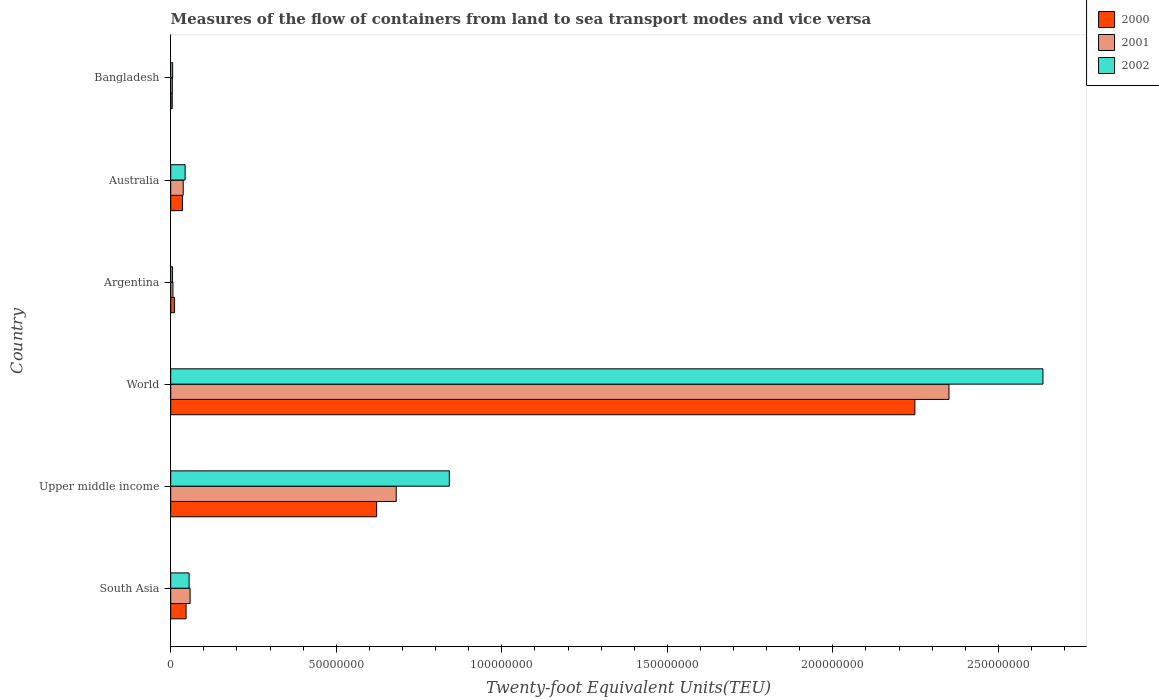How many groups of bars are there?
Offer a terse response. 6. Are the number of bars per tick equal to the number of legend labels?
Your answer should be very brief. Yes. Are the number of bars on each tick of the Y-axis equal?
Your response must be concise. Yes. How many bars are there on the 4th tick from the top?
Offer a very short reply. 3. How many bars are there on the 3rd tick from the bottom?
Give a very brief answer. 3. What is the container port traffic in 2001 in Bangladesh?
Offer a terse response. 4.86e+05. Across all countries, what is the maximum container port traffic in 2001?
Give a very brief answer. 2.35e+08. Across all countries, what is the minimum container port traffic in 2002?
Make the answer very short. 5.55e+05. In which country was the container port traffic in 2000 minimum?
Your answer should be compact. Bangladesh. What is the total container port traffic in 2001 in the graph?
Give a very brief answer. 3.14e+08. What is the difference between the container port traffic in 2002 in Australia and that in South Asia?
Offer a very short reply. -1.20e+06. What is the difference between the container port traffic in 2002 in Bangladesh and the container port traffic in 2000 in South Asia?
Provide a succinct answer. -4.06e+06. What is the average container port traffic in 2000 per country?
Offer a very short reply. 4.95e+07. What is the difference between the container port traffic in 2002 and container port traffic in 2001 in Argentina?
Provide a succinct answer. -1.09e+05. What is the ratio of the container port traffic in 2002 in South Asia to that in World?
Ensure brevity in your answer.  0.02. Is the container port traffic in 2000 in Australia less than that in Upper middle income?
Keep it short and to the point. Yes. What is the difference between the highest and the second highest container port traffic in 2000?
Make the answer very short. 1.63e+08. What is the difference between the highest and the lowest container port traffic in 2001?
Give a very brief answer. 2.35e+08. In how many countries, is the container port traffic in 2000 greater than the average container port traffic in 2000 taken over all countries?
Your response must be concise. 2. Is the sum of the container port traffic in 2000 in Australia and South Asia greater than the maximum container port traffic in 2002 across all countries?
Your response must be concise. No. What does the 1st bar from the bottom in World represents?
Your response must be concise. 2000. Is it the case that in every country, the sum of the container port traffic in 2002 and container port traffic in 2001 is greater than the container port traffic in 2000?
Provide a succinct answer. Yes. How many bars are there?
Offer a very short reply. 18. What is the difference between two consecutive major ticks on the X-axis?
Your answer should be compact. 5.00e+07. Are the values on the major ticks of X-axis written in scientific E-notation?
Ensure brevity in your answer.  No. Does the graph contain any zero values?
Offer a terse response. No. Does the graph contain grids?
Provide a short and direct response. No. Where does the legend appear in the graph?
Provide a succinct answer. Top right. What is the title of the graph?
Offer a terse response. Measures of the flow of containers from land to sea transport modes and vice versa. Does "2006" appear as one of the legend labels in the graph?
Your answer should be very brief. No. What is the label or title of the X-axis?
Make the answer very short. Twenty-foot Equivalent Units(TEU). What is the label or title of the Y-axis?
Ensure brevity in your answer.  Country. What is the Twenty-foot Equivalent Units(TEU) of 2000 in South Asia?
Your answer should be very brief. 4.64e+06. What is the Twenty-foot Equivalent Units(TEU) in 2001 in South Asia?
Make the answer very short. 5.86e+06. What is the Twenty-foot Equivalent Units(TEU) of 2002 in South Asia?
Give a very brief answer. 5.56e+06. What is the Twenty-foot Equivalent Units(TEU) of 2000 in Upper middle income?
Your answer should be very brief. 6.22e+07. What is the Twenty-foot Equivalent Units(TEU) of 2001 in Upper middle income?
Make the answer very short. 6.81e+07. What is the Twenty-foot Equivalent Units(TEU) in 2002 in Upper middle income?
Provide a short and direct response. 8.42e+07. What is the Twenty-foot Equivalent Units(TEU) in 2000 in World?
Give a very brief answer. 2.25e+08. What is the Twenty-foot Equivalent Units(TEU) of 2001 in World?
Make the answer very short. 2.35e+08. What is the Twenty-foot Equivalent Units(TEU) in 2002 in World?
Your answer should be very brief. 2.63e+08. What is the Twenty-foot Equivalent Units(TEU) of 2000 in Argentina?
Ensure brevity in your answer.  1.14e+06. What is the Twenty-foot Equivalent Units(TEU) of 2001 in Argentina?
Ensure brevity in your answer.  6.64e+05. What is the Twenty-foot Equivalent Units(TEU) of 2002 in Argentina?
Offer a very short reply. 5.55e+05. What is the Twenty-foot Equivalent Units(TEU) of 2000 in Australia?
Offer a very short reply. 3.54e+06. What is the Twenty-foot Equivalent Units(TEU) in 2001 in Australia?
Offer a terse response. 3.77e+06. What is the Twenty-foot Equivalent Units(TEU) in 2002 in Australia?
Your answer should be very brief. 4.36e+06. What is the Twenty-foot Equivalent Units(TEU) in 2000 in Bangladesh?
Your answer should be very brief. 4.56e+05. What is the Twenty-foot Equivalent Units(TEU) in 2001 in Bangladesh?
Make the answer very short. 4.86e+05. What is the Twenty-foot Equivalent Units(TEU) in 2002 in Bangladesh?
Provide a short and direct response. 5.84e+05. Across all countries, what is the maximum Twenty-foot Equivalent Units(TEU) in 2000?
Ensure brevity in your answer.  2.25e+08. Across all countries, what is the maximum Twenty-foot Equivalent Units(TEU) of 2001?
Your answer should be very brief. 2.35e+08. Across all countries, what is the maximum Twenty-foot Equivalent Units(TEU) of 2002?
Provide a succinct answer. 2.63e+08. Across all countries, what is the minimum Twenty-foot Equivalent Units(TEU) of 2000?
Provide a short and direct response. 4.56e+05. Across all countries, what is the minimum Twenty-foot Equivalent Units(TEU) of 2001?
Offer a very short reply. 4.86e+05. Across all countries, what is the minimum Twenty-foot Equivalent Units(TEU) of 2002?
Provide a succinct answer. 5.55e+05. What is the total Twenty-foot Equivalent Units(TEU) of 2000 in the graph?
Your response must be concise. 2.97e+08. What is the total Twenty-foot Equivalent Units(TEU) of 2001 in the graph?
Make the answer very short. 3.14e+08. What is the total Twenty-foot Equivalent Units(TEU) of 2002 in the graph?
Make the answer very short. 3.59e+08. What is the difference between the Twenty-foot Equivalent Units(TEU) of 2000 in South Asia and that in Upper middle income?
Give a very brief answer. -5.76e+07. What is the difference between the Twenty-foot Equivalent Units(TEU) of 2001 in South Asia and that in Upper middle income?
Provide a short and direct response. -6.23e+07. What is the difference between the Twenty-foot Equivalent Units(TEU) in 2002 in South Asia and that in Upper middle income?
Your answer should be compact. -7.86e+07. What is the difference between the Twenty-foot Equivalent Units(TEU) of 2000 in South Asia and that in World?
Ensure brevity in your answer.  -2.20e+08. What is the difference between the Twenty-foot Equivalent Units(TEU) of 2001 in South Asia and that in World?
Ensure brevity in your answer.  -2.29e+08. What is the difference between the Twenty-foot Equivalent Units(TEU) of 2002 in South Asia and that in World?
Your response must be concise. -2.58e+08. What is the difference between the Twenty-foot Equivalent Units(TEU) of 2000 in South Asia and that in Argentina?
Your response must be concise. 3.49e+06. What is the difference between the Twenty-foot Equivalent Units(TEU) in 2001 in South Asia and that in Argentina?
Provide a succinct answer. 5.19e+06. What is the difference between the Twenty-foot Equivalent Units(TEU) in 2002 in South Asia and that in Argentina?
Provide a succinct answer. 5.00e+06. What is the difference between the Twenty-foot Equivalent Units(TEU) of 2000 in South Asia and that in Australia?
Your answer should be very brief. 1.10e+06. What is the difference between the Twenty-foot Equivalent Units(TEU) of 2001 in South Asia and that in Australia?
Offer a very short reply. 2.08e+06. What is the difference between the Twenty-foot Equivalent Units(TEU) of 2002 in South Asia and that in Australia?
Provide a short and direct response. 1.20e+06. What is the difference between the Twenty-foot Equivalent Units(TEU) of 2000 in South Asia and that in Bangladesh?
Ensure brevity in your answer.  4.18e+06. What is the difference between the Twenty-foot Equivalent Units(TEU) in 2001 in South Asia and that in Bangladesh?
Your response must be concise. 5.37e+06. What is the difference between the Twenty-foot Equivalent Units(TEU) of 2002 in South Asia and that in Bangladesh?
Make the answer very short. 4.97e+06. What is the difference between the Twenty-foot Equivalent Units(TEU) of 2000 in Upper middle income and that in World?
Offer a very short reply. -1.63e+08. What is the difference between the Twenty-foot Equivalent Units(TEU) in 2001 in Upper middle income and that in World?
Provide a short and direct response. -1.67e+08. What is the difference between the Twenty-foot Equivalent Units(TEU) of 2002 in Upper middle income and that in World?
Your answer should be compact. -1.79e+08. What is the difference between the Twenty-foot Equivalent Units(TEU) of 2000 in Upper middle income and that in Argentina?
Keep it short and to the point. 6.11e+07. What is the difference between the Twenty-foot Equivalent Units(TEU) of 2001 in Upper middle income and that in Argentina?
Provide a succinct answer. 6.75e+07. What is the difference between the Twenty-foot Equivalent Units(TEU) of 2002 in Upper middle income and that in Argentina?
Ensure brevity in your answer.  8.36e+07. What is the difference between the Twenty-foot Equivalent Units(TEU) of 2000 in Upper middle income and that in Australia?
Your answer should be very brief. 5.87e+07. What is the difference between the Twenty-foot Equivalent Units(TEU) of 2001 in Upper middle income and that in Australia?
Give a very brief answer. 6.43e+07. What is the difference between the Twenty-foot Equivalent Units(TEU) of 2002 in Upper middle income and that in Australia?
Keep it short and to the point. 7.98e+07. What is the difference between the Twenty-foot Equivalent Units(TEU) of 2000 in Upper middle income and that in Bangladesh?
Offer a terse response. 6.17e+07. What is the difference between the Twenty-foot Equivalent Units(TEU) in 2001 in Upper middle income and that in Bangladesh?
Your answer should be compact. 6.76e+07. What is the difference between the Twenty-foot Equivalent Units(TEU) of 2002 in Upper middle income and that in Bangladesh?
Your answer should be very brief. 8.36e+07. What is the difference between the Twenty-foot Equivalent Units(TEU) of 2000 in World and that in Argentina?
Keep it short and to the point. 2.24e+08. What is the difference between the Twenty-foot Equivalent Units(TEU) in 2001 in World and that in Argentina?
Offer a very short reply. 2.34e+08. What is the difference between the Twenty-foot Equivalent Units(TEU) of 2002 in World and that in Argentina?
Give a very brief answer. 2.63e+08. What is the difference between the Twenty-foot Equivalent Units(TEU) of 2000 in World and that in Australia?
Provide a short and direct response. 2.21e+08. What is the difference between the Twenty-foot Equivalent Units(TEU) of 2001 in World and that in Australia?
Provide a short and direct response. 2.31e+08. What is the difference between the Twenty-foot Equivalent Units(TEU) of 2002 in World and that in Australia?
Your response must be concise. 2.59e+08. What is the difference between the Twenty-foot Equivalent Units(TEU) of 2000 in World and that in Bangladesh?
Your response must be concise. 2.24e+08. What is the difference between the Twenty-foot Equivalent Units(TEU) of 2001 in World and that in Bangladesh?
Give a very brief answer. 2.35e+08. What is the difference between the Twenty-foot Equivalent Units(TEU) in 2002 in World and that in Bangladesh?
Give a very brief answer. 2.63e+08. What is the difference between the Twenty-foot Equivalent Units(TEU) in 2000 in Argentina and that in Australia?
Keep it short and to the point. -2.40e+06. What is the difference between the Twenty-foot Equivalent Units(TEU) in 2001 in Argentina and that in Australia?
Offer a very short reply. -3.11e+06. What is the difference between the Twenty-foot Equivalent Units(TEU) of 2002 in Argentina and that in Australia?
Keep it short and to the point. -3.80e+06. What is the difference between the Twenty-foot Equivalent Units(TEU) of 2000 in Argentina and that in Bangladesh?
Offer a terse response. 6.89e+05. What is the difference between the Twenty-foot Equivalent Units(TEU) in 2001 in Argentina and that in Bangladesh?
Ensure brevity in your answer.  1.78e+05. What is the difference between the Twenty-foot Equivalent Units(TEU) of 2002 in Argentina and that in Bangladesh?
Your answer should be very brief. -2.94e+04. What is the difference between the Twenty-foot Equivalent Units(TEU) in 2000 in Australia and that in Bangladesh?
Your answer should be compact. 3.09e+06. What is the difference between the Twenty-foot Equivalent Units(TEU) in 2001 in Australia and that in Bangladesh?
Make the answer very short. 3.29e+06. What is the difference between the Twenty-foot Equivalent Units(TEU) in 2002 in Australia and that in Bangladesh?
Your answer should be compact. 3.77e+06. What is the difference between the Twenty-foot Equivalent Units(TEU) in 2000 in South Asia and the Twenty-foot Equivalent Units(TEU) in 2001 in Upper middle income?
Your response must be concise. -6.35e+07. What is the difference between the Twenty-foot Equivalent Units(TEU) of 2000 in South Asia and the Twenty-foot Equivalent Units(TEU) of 2002 in Upper middle income?
Your answer should be compact. -7.95e+07. What is the difference between the Twenty-foot Equivalent Units(TEU) in 2001 in South Asia and the Twenty-foot Equivalent Units(TEU) in 2002 in Upper middle income?
Keep it short and to the point. -7.83e+07. What is the difference between the Twenty-foot Equivalent Units(TEU) of 2000 in South Asia and the Twenty-foot Equivalent Units(TEU) of 2001 in World?
Ensure brevity in your answer.  -2.30e+08. What is the difference between the Twenty-foot Equivalent Units(TEU) in 2000 in South Asia and the Twenty-foot Equivalent Units(TEU) in 2002 in World?
Make the answer very short. -2.59e+08. What is the difference between the Twenty-foot Equivalent Units(TEU) of 2001 in South Asia and the Twenty-foot Equivalent Units(TEU) of 2002 in World?
Your answer should be compact. -2.58e+08. What is the difference between the Twenty-foot Equivalent Units(TEU) in 2000 in South Asia and the Twenty-foot Equivalent Units(TEU) in 2001 in Argentina?
Provide a short and direct response. 3.98e+06. What is the difference between the Twenty-foot Equivalent Units(TEU) in 2000 in South Asia and the Twenty-foot Equivalent Units(TEU) in 2002 in Argentina?
Ensure brevity in your answer.  4.08e+06. What is the difference between the Twenty-foot Equivalent Units(TEU) of 2001 in South Asia and the Twenty-foot Equivalent Units(TEU) of 2002 in Argentina?
Your answer should be compact. 5.30e+06. What is the difference between the Twenty-foot Equivalent Units(TEU) in 2000 in South Asia and the Twenty-foot Equivalent Units(TEU) in 2001 in Australia?
Give a very brief answer. 8.65e+05. What is the difference between the Twenty-foot Equivalent Units(TEU) of 2000 in South Asia and the Twenty-foot Equivalent Units(TEU) of 2002 in Australia?
Your answer should be compact. 2.84e+05. What is the difference between the Twenty-foot Equivalent Units(TEU) in 2001 in South Asia and the Twenty-foot Equivalent Units(TEU) in 2002 in Australia?
Provide a succinct answer. 1.50e+06. What is the difference between the Twenty-foot Equivalent Units(TEU) in 2000 in South Asia and the Twenty-foot Equivalent Units(TEU) in 2001 in Bangladesh?
Make the answer very short. 4.15e+06. What is the difference between the Twenty-foot Equivalent Units(TEU) of 2000 in South Asia and the Twenty-foot Equivalent Units(TEU) of 2002 in Bangladesh?
Make the answer very short. 4.06e+06. What is the difference between the Twenty-foot Equivalent Units(TEU) of 2001 in South Asia and the Twenty-foot Equivalent Units(TEU) of 2002 in Bangladesh?
Make the answer very short. 5.27e+06. What is the difference between the Twenty-foot Equivalent Units(TEU) in 2000 in Upper middle income and the Twenty-foot Equivalent Units(TEU) in 2001 in World?
Keep it short and to the point. -1.73e+08. What is the difference between the Twenty-foot Equivalent Units(TEU) of 2000 in Upper middle income and the Twenty-foot Equivalent Units(TEU) of 2002 in World?
Offer a very short reply. -2.01e+08. What is the difference between the Twenty-foot Equivalent Units(TEU) in 2001 in Upper middle income and the Twenty-foot Equivalent Units(TEU) in 2002 in World?
Keep it short and to the point. -1.95e+08. What is the difference between the Twenty-foot Equivalent Units(TEU) of 2000 in Upper middle income and the Twenty-foot Equivalent Units(TEU) of 2001 in Argentina?
Offer a very short reply. 6.15e+07. What is the difference between the Twenty-foot Equivalent Units(TEU) in 2000 in Upper middle income and the Twenty-foot Equivalent Units(TEU) in 2002 in Argentina?
Provide a short and direct response. 6.16e+07. What is the difference between the Twenty-foot Equivalent Units(TEU) in 2001 in Upper middle income and the Twenty-foot Equivalent Units(TEU) in 2002 in Argentina?
Your response must be concise. 6.76e+07. What is the difference between the Twenty-foot Equivalent Units(TEU) of 2000 in Upper middle income and the Twenty-foot Equivalent Units(TEU) of 2001 in Australia?
Your answer should be very brief. 5.84e+07. What is the difference between the Twenty-foot Equivalent Units(TEU) of 2000 in Upper middle income and the Twenty-foot Equivalent Units(TEU) of 2002 in Australia?
Keep it short and to the point. 5.78e+07. What is the difference between the Twenty-foot Equivalent Units(TEU) in 2001 in Upper middle income and the Twenty-foot Equivalent Units(TEU) in 2002 in Australia?
Ensure brevity in your answer.  6.38e+07. What is the difference between the Twenty-foot Equivalent Units(TEU) of 2000 in Upper middle income and the Twenty-foot Equivalent Units(TEU) of 2001 in Bangladesh?
Provide a short and direct response. 6.17e+07. What is the difference between the Twenty-foot Equivalent Units(TEU) of 2000 in Upper middle income and the Twenty-foot Equivalent Units(TEU) of 2002 in Bangladesh?
Your answer should be very brief. 6.16e+07. What is the difference between the Twenty-foot Equivalent Units(TEU) of 2001 in Upper middle income and the Twenty-foot Equivalent Units(TEU) of 2002 in Bangladesh?
Offer a terse response. 6.75e+07. What is the difference between the Twenty-foot Equivalent Units(TEU) of 2000 in World and the Twenty-foot Equivalent Units(TEU) of 2001 in Argentina?
Offer a very short reply. 2.24e+08. What is the difference between the Twenty-foot Equivalent Units(TEU) in 2000 in World and the Twenty-foot Equivalent Units(TEU) in 2002 in Argentina?
Make the answer very short. 2.24e+08. What is the difference between the Twenty-foot Equivalent Units(TEU) in 2001 in World and the Twenty-foot Equivalent Units(TEU) in 2002 in Argentina?
Provide a succinct answer. 2.35e+08. What is the difference between the Twenty-foot Equivalent Units(TEU) of 2000 in World and the Twenty-foot Equivalent Units(TEU) of 2001 in Australia?
Give a very brief answer. 2.21e+08. What is the difference between the Twenty-foot Equivalent Units(TEU) in 2000 in World and the Twenty-foot Equivalent Units(TEU) in 2002 in Australia?
Provide a short and direct response. 2.20e+08. What is the difference between the Twenty-foot Equivalent Units(TEU) of 2001 in World and the Twenty-foot Equivalent Units(TEU) of 2002 in Australia?
Keep it short and to the point. 2.31e+08. What is the difference between the Twenty-foot Equivalent Units(TEU) in 2000 in World and the Twenty-foot Equivalent Units(TEU) in 2001 in Bangladesh?
Keep it short and to the point. 2.24e+08. What is the difference between the Twenty-foot Equivalent Units(TEU) in 2000 in World and the Twenty-foot Equivalent Units(TEU) in 2002 in Bangladesh?
Offer a very short reply. 2.24e+08. What is the difference between the Twenty-foot Equivalent Units(TEU) of 2001 in World and the Twenty-foot Equivalent Units(TEU) of 2002 in Bangladesh?
Your answer should be very brief. 2.34e+08. What is the difference between the Twenty-foot Equivalent Units(TEU) in 2000 in Argentina and the Twenty-foot Equivalent Units(TEU) in 2001 in Australia?
Provide a short and direct response. -2.63e+06. What is the difference between the Twenty-foot Equivalent Units(TEU) of 2000 in Argentina and the Twenty-foot Equivalent Units(TEU) of 2002 in Australia?
Your answer should be compact. -3.21e+06. What is the difference between the Twenty-foot Equivalent Units(TEU) in 2001 in Argentina and the Twenty-foot Equivalent Units(TEU) in 2002 in Australia?
Make the answer very short. -3.69e+06. What is the difference between the Twenty-foot Equivalent Units(TEU) in 2000 in Argentina and the Twenty-foot Equivalent Units(TEU) in 2001 in Bangladesh?
Offer a very short reply. 6.59e+05. What is the difference between the Twenty-foot Equivalent Units(TEU) in 2000 in Argentina and the Twenty-foot Equivalent Units(TEU) in 2002 in Bangladesh?
Offer a very short reply. 5.61e+05. What is the difference between the Twenty-foot Equivalent Units(TEU) in 2001 in Argentina and the Twenty-foot Equivalent Units(TEU) in 2002 in Bangladesh?
Make the answer very short. 7.96e+04. What is the difference between the Twenty-foot Equivalent Units(TEU) in 2000 in Australia and the Twenty-foot Equivalent Units(TEU) in 2001 in Bangladesh?
Your answer should be very brief. 3.06e+06. What is the difference between the Twenty-foot Equivalent Units(TEU) in 2000 in Australia and the Twenty-foot Equivalent Units(TEU) in 2002 in Bangladesh?
Ensure brevity in your answer.  2.96e+06. What is the difference between the Twenty-foot Equivalent Units(TEU) of 2001 in Australia and the Twenty-foot Equivalent Units(TEU) of 2002 in Bangladesh?
Provide a short and direct response. 3.19e+06. What is the average Twenty-foot Equivalent Units(TEU) in 2000 per country?
Ensure brevity in your answer.  4.95e+07. What is the average Twenty-foot Equivalent Units(TEU) of 2001 per country?
Offer a very short reply. 5.23e+07. What is the average Twenty-foot Equivalent Units(TEU) of 2002 per country?
Your response must be concise. 5.98e+07. What is the difference between the Twenty-foot Equivalent Units(TEU) in 2000 and Twenty-foot Equivalent Units(TEU) in 2001 in South Asia?
Ensure brevity in your answer.  -1.22e+06. What is the difference between the Twenty-foot Equivalent Units(TEU) in 2000 and Twenty-foot Equivalent Units(TEU) in 2002 in South Asia?
Provide a succinct answer. -9.18e+05. What is the difference between the Twenty-foot Equivalent Units(TEU) of 2001 and Twenty-foot Equivalent Units(TEU) of 2002 in South Asia?
Your answer should be very brief. 2.99e+05. What is the difference between the Twenty-foot Equivalent Units(TEU) of 2000 and Twenty-foot Equivalent Units(TEU) of 2001 in Upper middle income?
Ensure brevity in your answer.  -5.92e+06. What is the difference between the Twenty-foot Equivalent Units(TEU) of 2000 and Twenty-foot Equivalent Units(TEU) of 2002 in Upper middle income?
Provide a short and direct response. -2.20e+07. What is the difference between the Twenty-foot Equivalent Units(TEU) of 2001 and Twenty-foot Equivalent Units(TEU) of 2002 in Upper middle income?
Provide a succinct answer. -1.60e+07. What is the difference between the Twenty-foot Equivalent Units(TEU) of 2000 and Twenty-foot Equivalent Units(TEU) of 2001 in World?
Give a very brief answer. -1.03e+07. What is the difference between the Twenty-foot Equivalent Units(TEU) in 2000 and Twenty-foot Equivalent Units(TEU) in 2002 in World?
Ensure brevity in your answer.  -3.87e+07. What is the difference between the Twenty-foot Equivalent Units(TEU) in 2001 and Twenty-foot Equivalent Units(TEU) in 2002 in World?
Your response must be concise. -2.84e+07. What is the difference between the Twenty-foot Equivalent Units(TEU) in 2000 and Twenty-foot Equivalent Units(TEU) in 2001 in Argentina?
Give a very brief answer. 4.81e+05. What is the difference between the Twenty-foot Equivalent Units(TEU) in 2000 and Twenty-foot Equivalent Units(TEU) in 2002 in Argentina?
Provide a succinct answer. 5.90e+05. What is the difference between the Twenty-foot Equivalent Units(TEU) of 2001 and Twenty-foot Equivalent Units(TEU) of 2002 in Argentina?
Make the answer very short. 1.09e+05. What is the difference between the Twenty-foot Equivalent Units(TEU) in 2000 and Twenty-foot Equivalent Units(TEU) in 2001 in Australia?
Provide a short and direct response. -2.32e+05. What is the difference between the Twenty-foot Equivalent Units(TEU) in 2000 and Twenty-foot Equivalent Units(TEU) in 2002 in Australia?
Offer a terse response. -8.12e+05. What is the difference between the Twenty-foot Equivalent Units(TEU) in 2001 and Twenty-foot Equivalent Units(TEU) in 2002 in Australia?
Keep it short and to the point. -5.80e+05. What is the difference between the Twenty-foot Equivalent Units(TEU) of 2000 and Twenty-foot Equivalent Units(TEU) of 2001 in Bangladesh?
Your response must be concise. -3.03e+04. What is the difference between the Twenty-foot Equivalent Units(TEU) of 2000 and Twenty-foot Equivalent Units(TEU) of 2002 in Bangladesh?
Offer a very short reply. -1.28e+05. What is the difference between the Twenty-foot Equivalent Units(TEU) in 2001 and Twenty-foot Equivalent Units(TEU) in 2002 in Bangladesh?
Make the answer very short. -9.79e+04. What is the ratio of the Twenty-foot Equivalent Units(TEU) of 2000 in South Asia to that in Upper middle income?
Make the answer very short. 0.07. What is the ratio of the Twenty-foot Equivalent Units(TEU) in 2001 in South Asia to that in Upper middle income?
Offer a very short reply. 0.09. What is the ratio of the Twenty-foot Equivalent Units(TEU) of 2002 in South Asia to that in Upper middle income?
Ensure brevity in your answer.  0.07. What is the ratio of the Twenty-foot Equivalent Units(TEU) in 2000 in South Asia to that in World?
Ensure brevity in your answer.  0.02. What is the ratio of the Twenty-foot Equivalent Units(TEU) in 2001 in South Asia to that in World?
Provide a succinct answer. 0.02. What is the ratio of the Twenty-foot Equivalent Units(TEU) of 2002 in South Asia to that in World?
Offer a very short reply. 0.02. What is the ratio of the Twenty-foot Equivalent Units(TEU) of 2000 in South Asia to that in Argentina?
Provide a succinct answer. 4.05. What is the ratio of the Twenty-foot Equivalent Units(TEU) of 2001 in South Asia to that in Argentina?
Provide a short and direct response. 8.82. What is the ratio of the Twenty-foot Equivalent Units(TEU) in 2002 in South Asia to that in Argentina?
Your answer should be compact. 10.02. What is the ratio of the Twenty-foot Equivalent Units(TEU) in 2000 in South Asia to that in Australia?
Keep it short and to the point. 1.31. What is the ratio of the Twenty-foot Equivalent Units(TEU) of 2001 in South Asia to that in Australia?
Offer a terse response. 1.55. What is the ratio of the Twenty-foot Equivalent Units(TEU) of 2002 in South Asia to that in Australia?
Provide a short and direct response. 1.28. What is the ratio of the Twenty-foot Equivalent Units(TEU) of 2000 in South Asia to that in Bangladesh?
Offer a very short reply. 10.17. What is the ratio of the Twenty-foot Equivalent Units(TEU) of 2001 in South Asia to that in Bangladesh?
Offer a terse response. 12.04. What is the ratio of the Twenty-foot Equivalent Units(TEU) of 2002 in South Asia to that in Bangladesh?
Make the answer very short. 9.51. What is the ratio of the Twenty-foot Equivalent Units(TEU) in 2000 in Upper middle income to that in World?
Your answer should be compact. 0.28. What is the ratio of the Twenty-foot Equivalent Units(TEU) of 2001 in Upper middle income to that in World?
Provide a short and direct response. 0.29. What is the ratio of the Twenty-foot Equivalent Units(TEU) of 2002 in Upper middle income to that in World?
Provide a succinct answer. 0.32. What is the ratio of the Twenty-foot Equivalent Units(TEU) of 2000 in Upper middle income to that in Argentina?
Ensure brevity in your answer.  54.33. What is the ratio of the Twenty-foot Equivalent Units(TEU) in 2001 in Upper middle income to that in Argentina?
Offer a very short reply. 102.62. What is the ratio of the Twenty-foot Equivalent Units(TEU) of 2002 in Upper middle income to that in Argentina?
Your answer should be very brief. 151.68. What is the ratio of the Twenty-foot Equivalent Units(TEU) of 2000 in Upper middle income to that in Australia?
Your answer should be very brief. 17.56. What is the ratio of the Twenty-foot Equivalent Units(TEU) in 2001 in Upper middle income to that in Australia?
Keep it short and to the point. 18.05. What is the ratio of the Twenty-foot Equivalent Units(TEU) in 2002 in Upper middle income to that in Australia?
Keep it short and to the point. 19.32. What is the ratio of the Twenty-foot Equivalent Units(TEU) in 2000 in Upper middle income to that in Bangladesh?
Provide a short and direct response. 136.4. What is the ratio of the Twenty-foot Equivalent Units(TEU) in 2001 in Upper middle income to that in Bangladesh?
Your answer should be very brief. 140.08. What is the ratio of the Twenty-foot Equivalent Units(TEU) of 2002 in Upper middle income to that in Bangladesh?
Ensure brevity in your answer.  144.04. What is the ratio of the Twenty-foot Equivalent Units(TEU) in 2000 in World to that in Argentina?
Provide a short and direct response. 196.34. What is the ratio of the Twenty-foot Equivalent Units(TEU) of 2001 in World to that in Argentina?
Provide a succinct answer. 354.13. What is the ratio of the Twenty-foot Equivalent Units(TEU) in 2002 in World to that in Argentina?
Offer a very short reply. 474.87. What is the ratio of the Twenty-foot Equivalent Units(TEU) of 2000 in World to that in Australia?
Provide a short and direct response. 63.45. What is the ratio of the Twenty-foot Equivalent Units(TEU) in 2001 in World to that in Australia?
Your answer should be very brief. 62.27. What is the ratio of the Twenty-foot Equivalent Units(TEU) of 2002 in World to that in Australia?
Your response must be concise. 60.49. What is the ratio of the Twenty-foot Equivalent Units(TEU) in 2000 in World to that in Bangladesh?
Offer a very short reply. 492.92. What is the ratio of the Twenty-foot Equivalent Units(TEU) in 2001 in World to that in Bangladesh?
Offer a very short reply. 483.41. What is the ratio of the Twenty-foot Equivalent Units(TEU) in 2002 in World to that in Bangladesh?
Offer a very short reply. 450.95. What is the ratio of the Twenty-foot Equivalent Units(TEU) of 2000 in Argentina to that in Australia?
Keep it short and to the point. 0.32. What is the ratio of the Twenty-foot Equivalent Units(TEU) of 2001 in Argentina to that in Australia?
Give a very brief answer. 0.18. What is the ratio of the Twenty-foot Equivalent Units(TEU) of 2002 in Argentina to that in Australia?
Your answer should be very brief. 0.13. What is the ratio of the Twenty-foot Equivalent Units(TEU) in 2000 in Argentina to that in Bangladesh?
Your answer should be very brief. 2.51. What is the ratio of the Twenty-foot Equivalent Units(TEU) in 2001 in Argentina to that in Bangladesh?
Give a very brief answer. 1.37. What is the ratio of the Twenty-foot Equivalent Units(TEU) in 2002 in Argentina to that in Bangladesh?
Your answer should be compact. 0.95. What is the ratio of the Twenty-foot Equivalent Units(TEU) of 2000 in Australia to that in Bangladesh?
Your response must be concise. 7.77. What is the ratio of the Twenty-foot Equivalent Units(TEU) in 2001 in Australia to that in Bangladesh?
Give a very brief answer. 7.76. What is the ratio of the Twenty-foot Equivalent Units(TEU) of 2002 in Australia to that in Bangladesh?
Offer a terse response. 7.45. What is the difference between the highest and the second highest Twenty-foot Equivalent Units(TEU) of 2000?
Your answer should be compact. 1.63e+08. What is the difference between the highest and the second highest Twenty-foot Equivalent Units(TEU) of 2001?
Your answer should be compact. 1.67e+08. What is the difference between the highest and the second highest Twenty-foot Equivalent Units(TEU) of 2002?
Provide a short and direct response. 1.79e+08. What is the difference between the highest and the lowest Twenty-foot Equivalent Units(TEU) of 2000?
Provide a short and direct response. 2.24e+08. What is the difference between the highest and the lowest Twenty-foot Equivalent Units(TEU) in 2001?
Your answer should be very brief. 2.35e+08. What is the difference between the highest and the lowest Twenty-foot Equivalent Units(TEU) in 2002?
Your answer should be very brief. 2.63e+08. 